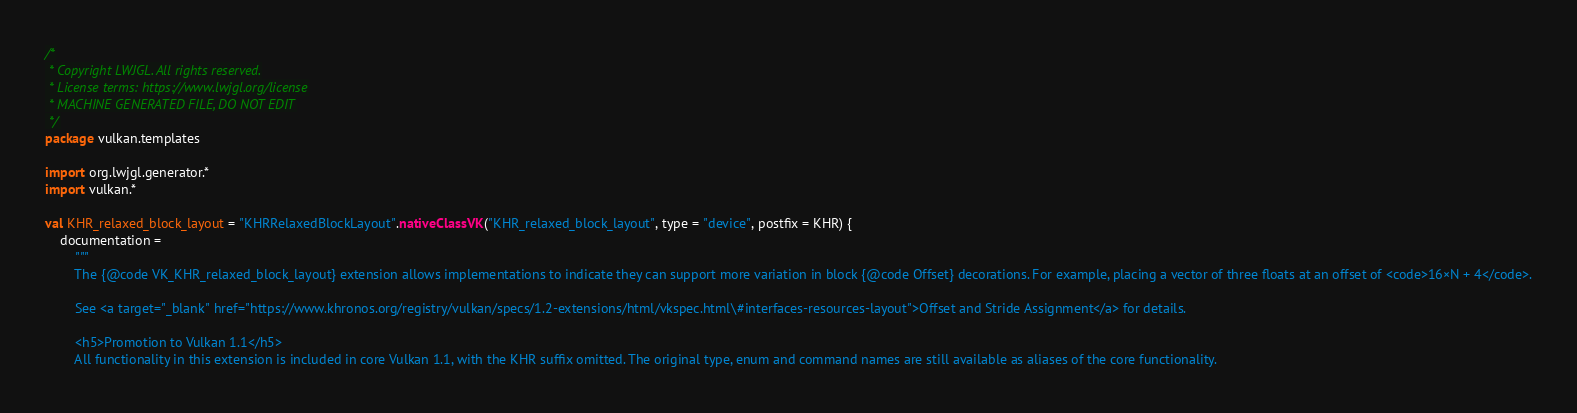<code> <loc_0><loc_0><loc_500><loc_500><_Kotlin_>/*
 * Copyright LWJGL. All rights reserved.
 * License terms: https://www.lwjgl.org/license
 * MACHINE GENERATED FILE, DO NOT EDIT
 */
package vulkan.templates

import org.lwjgl.generator.*
import vulkan.*

val KHR_relaxed_block_layout = "KHRRelaxedBlockLayout".nativeClassVK("KHR_relaxed_block_layout", type = "device", postfix = KHR) {
    documentation =
        """
        The {@code VK_KHR_relaxed_block_layout} extension allows implementations to indicate they can support more variation in block {@code Offset} decorations. For example, placing a vector of three floats at an offset of <code>16×N + 4</code>.

        See <a target="_blank" href="https://www.khronos.org/registry/vulkan/specs/1.2-extensions/html/vkspec.html\#interfaces-resources-layout">Offset and Stride Assignment</a> for details.

        <h5>Promotion to Vulkan 1.1</h5>
        All functionality in this extension is included in core Vulkan 1.1, with the KHR suffix omitted. The original type, enum and command names are still available as aliases of the core functionality.
</code> 